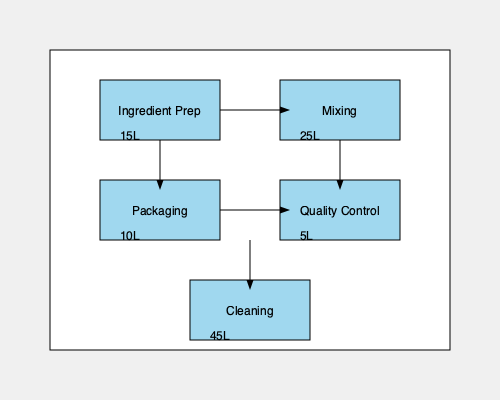Given the flowchart depicting water usage in various stages of product manufacturing, what percentage of the total water consumption is used in the cleaning process? To calculate the percentage of water used in the cleaning process, we need to follow these steps:

1. Calculate the total water usage:
   Ingredient Prep: 15L
   Mixing: 25L
   Packaging: 10L
   Quality Control: 5L
   Cleaning: 45L
   Total = 15 + 25 + 10 + 5 + 45 = 100L

2. Identify the water usage for cleaning:
   Cleaning process uses 45L

3. Calculate the percentage:
   Percentage = (Water used in cleaning / Total water usage) × 100
   = (45L / 100L) × 100
   = 0.45 × 100
   = 45%

Therefore, the cleaning process uses 45% of the total water consumption in the product manufacturing.
Answer: 45% 